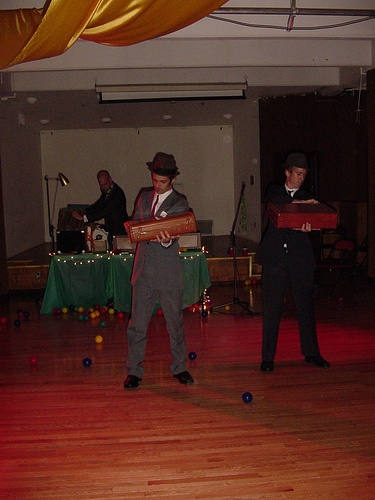Describe the objects in this image and their specific colors. I can see people in gray, black, maroon, brown, and darkgray tones, people in gray, black, maroon, and brown tones, people in gray, black, and maroon tones, suitcase in black, maroon, brown, and gray tones, and suitcase in gray, maroon, brown, and black tones in this image. 